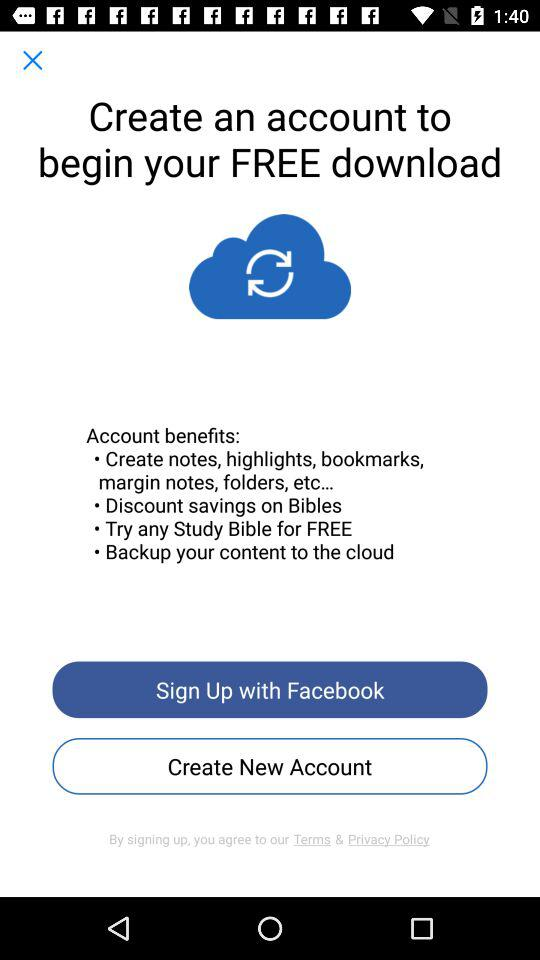Through which application can we sign up? You can sign up through "Facebook". 